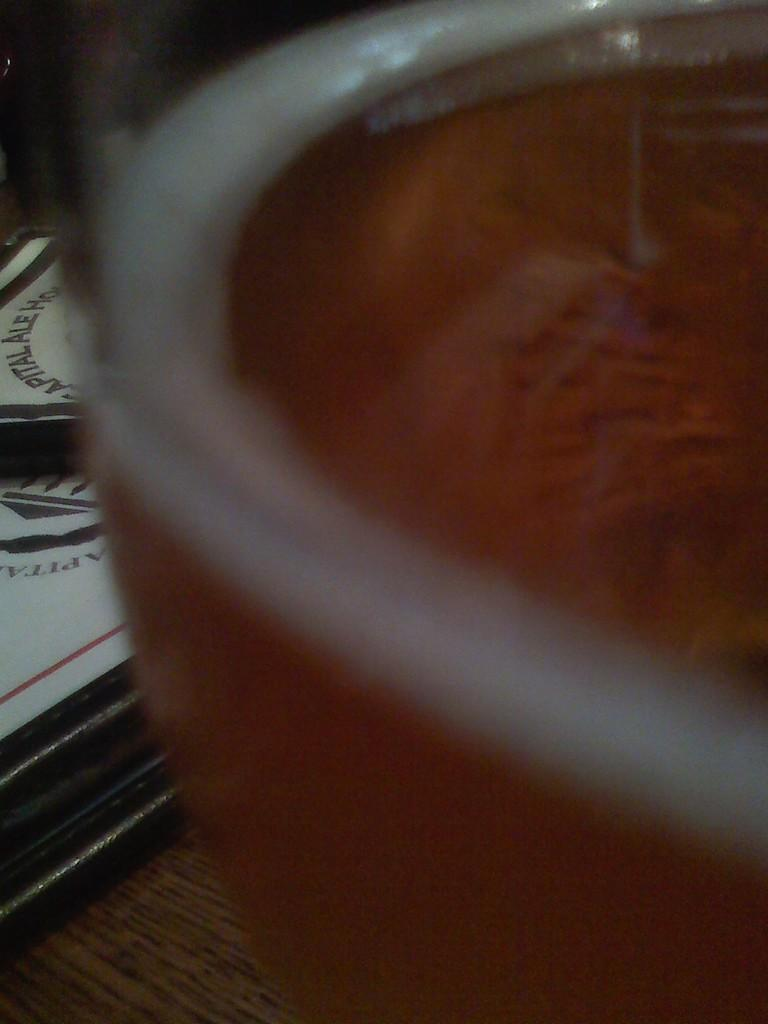What is the glass object containing in the image? The glass object contains liquid in the image. What can be seen on the wooden surface on the left side of the image? There are photo frames on the wooden surface on the left side of the image. What type of curtain is hanging in front of the glass object in the image? There is no curtain present in the image; it only features a glass object with liquid and photo frames on a wooden surface. 